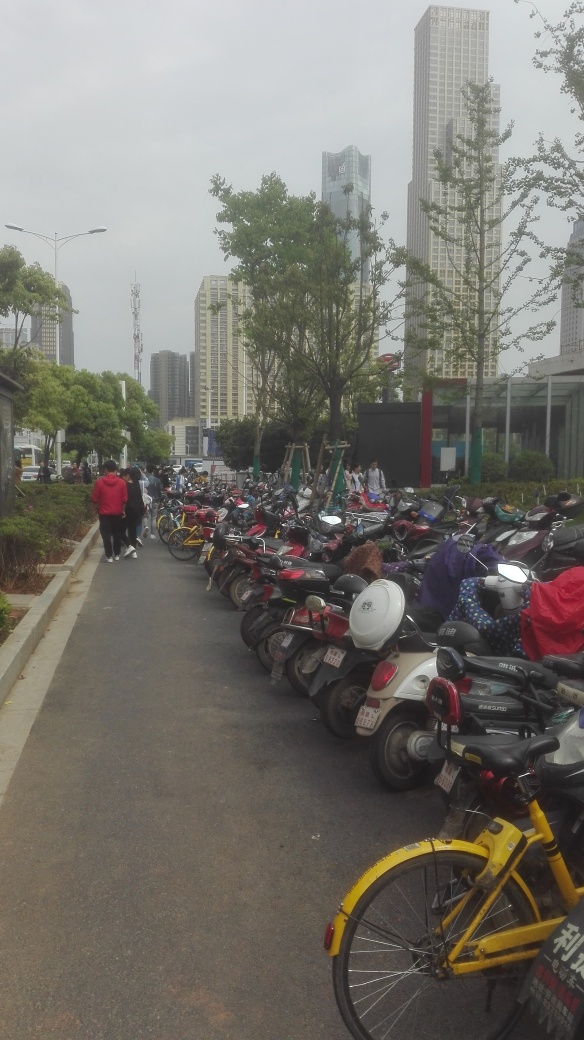What can you say about the transportation habits of the people in this area? Based on the large number of motorcycles and bicycles, it seems that many people in this area prefer these modes of transportation for their commutes. This choice might be due to convenience, cost efficiency, or the urban layout that favors such vehicles. 